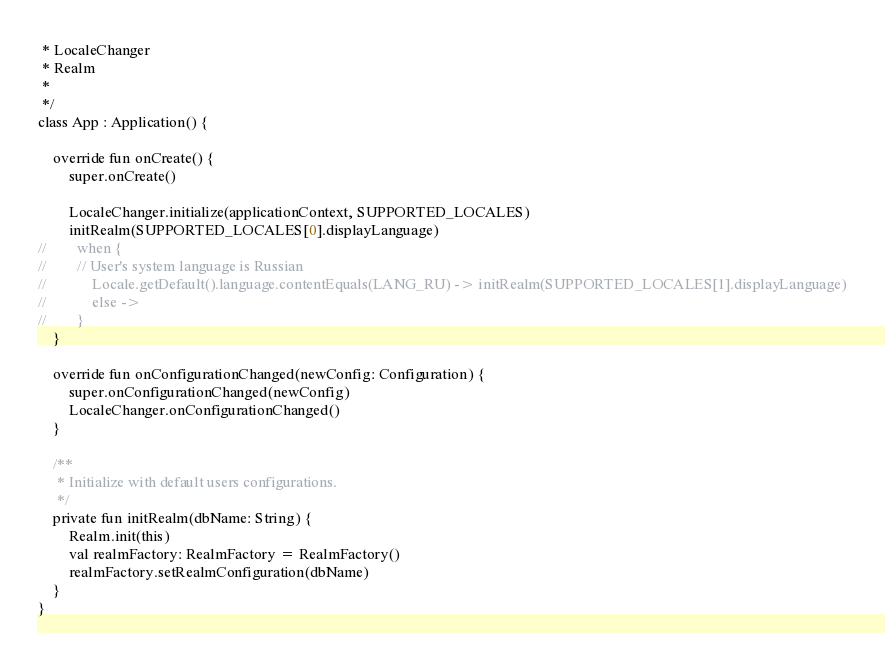Convert code to text. <code><loc_0><loc_0><loc_500><loc_500><_Kotlin_> * LocaleChanger
 * Realm
 *
 */
class App : Application() {

    override fun onCreate() {
        super.onCreate()

        LocaleChanger.initialize(applicationContext, SUPPORTED_LOCALES)
        initRealm(SUPPORTED_LOCALES[0].displayLanguage)
//        when {
//        // User's system language is Russian
//            Locale.getDefault().language.contentEquals(LANG_RU) -> initRealm(SUPPORTED_LOCALES[1].displayLanguage)
//            else ->
//        }
    }

    override fun onConfigurationChanged(newConfig: Configuration) {
        super.onConfigurationChanged(newConfig)
        LocaleChanger.onConfigurationChanged()
    }

    /**
     * Initialize with default users configurations.
     */
    private fun initRealm(dbName: String) {
        Realm.init(this)
        val realmFactory: RealmFactory = RealmFactory()
        realmFactory.setRealmConfiguration(dbName)
    }
}
</code> 